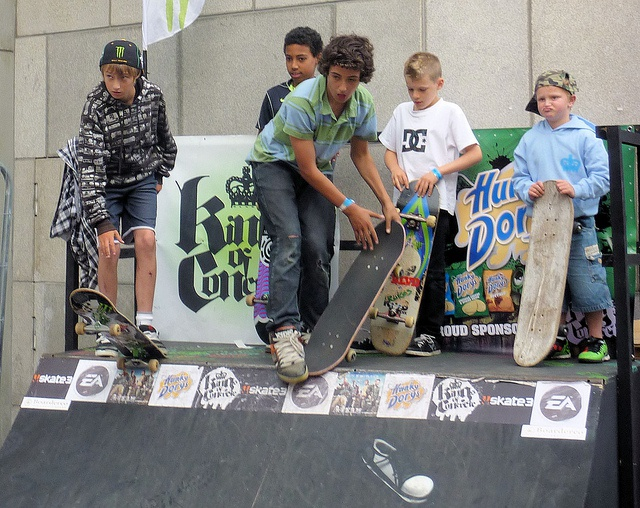Describe the objects in this image and their specific colors. I can see people in darkgray, black, gray, and brown tones, people in darkgray, lightgray, black, and gray tones, people in darkgray, black, and gray tones, people in darkgray, lightblue, black, and gray tones, and skateboard in darkgray and lightgray tones in this image. 